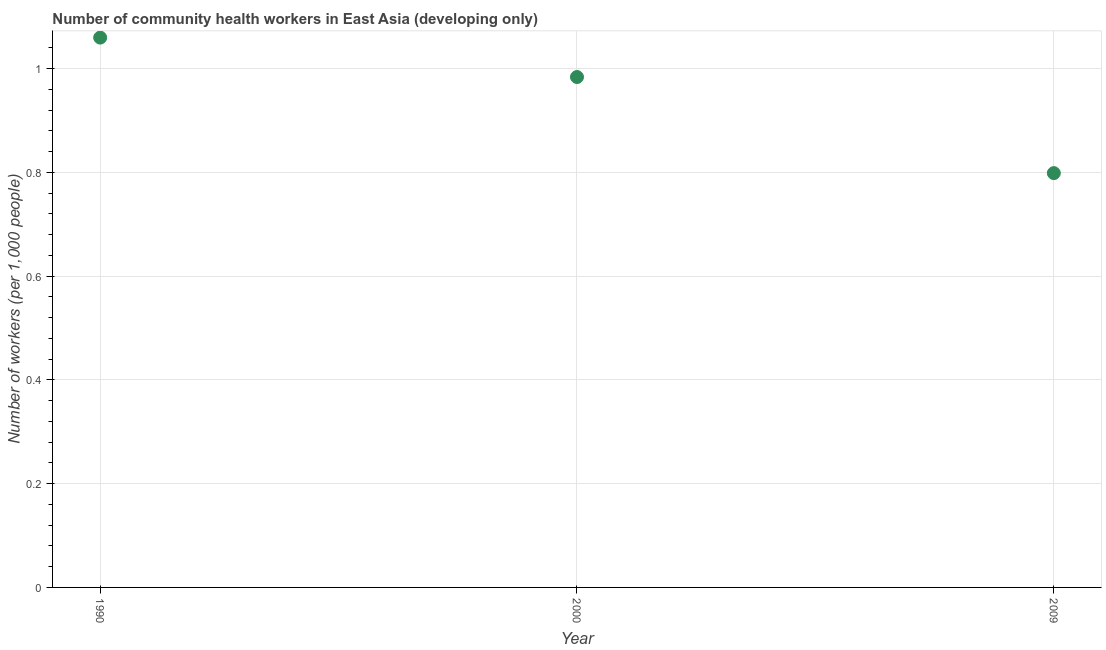What is the number of community health workers in 1990?
Provide a succinct answer. 1.06. Across all years, what is the maximum number of community health workers?
Provide a short and direct response. 1.06. Across all years, what is the minimum number of community health workers?
Keep it short and to the point. 0.8. In which year was the number of community health workers minimum?
Offer a very short reply. 2009. What is the sum of the number of community health workers?
Offer a terse response. 2.84. What is the difference between the number of community health workers in 2000 and 2009?
Offer a very short reply. 0.19. What is the average number of community health workers per year?
Offer a very short reply. 0.95. What is the median number of community health workers?
Provide a succinct answer. 0.98. In how many years, is the number of community health workers greater than 0.2 ?
Provide a succinct answer. 3. Do a majority of the years between 2009 and 2000 (inclusive) have number of community health workers greater than 0.88 ?
Give a very brief answer. No. What is the ratio of the number of community health workers in 1990 to that in 2000?
Offer a terse response. 1.08. What is the difference between the highest and the second highest number of community health workers?
Provide a succinct answer. 0.08. Is the sum of the number of community health workers in 1990 and 2009 greater than the maximum number of community health workers across all years?
Provide a short and direct response. Yes. What is the difference between the highest and the lowest number of community health workers?
Ensure brevity in your answer.  0.26. In how many years, is the number of community health workers greater than the average number of community health workers taken over all years?
Provide a short and direct response. 2. How many dotlines are there?
Ensure brevity in your answer.  1. What is the difference between two consecutive major ticks on the Y-axis?
Provide a succinct answer. 0.2. Are the values on the major ticks of Y-axis written in scientific E-notation?
Your response must be concise. No. Does the graph contain any zero values?
Offer a terse response. No. What is the title of the graph?
Keep it short and to the point. Number of community health workers in East Asia (developing only). What is the label or title of the X-axis?
Offer a very short reply. Year. What is the label or title of the Y-axis?
Provide a short and direct response. Number of workers (per 1,0 people). What is the Number of workers (per 1,000 people) in 1990?
Give a very brief answer. 1.06. What is the Number of workers (per 1,000 people) in 2000?
Provide a succinct answer. 0.98. What is the Number of workers (per 1,000 people) in 2009?
Your response must be concise. 0.8. What is the difference between the Number of workers (per 1,000 people) in 1990 and 2000?
Offer a very short reply. 0.08. What is the difference between the Number of workers (per 1,000 people) in 1990 and 2009?
Offer a terse response. 0.26. What is the difference between the Number of workers (per 1,000 people) in 2000 and 2009?
Your response must be concise. 0.19. What is the ratio of the Number of workers (per 1,000 people) in 1990 to that in 2000?
Keep it short and to the point. 1.08. What is the ratio of the Number of workers (per 1,000 people) in 1990 to that in 2009?
Give a very brief answer. 1.33. What is the ratio of the Number of workers (per 1,000 people) in 2000 to that in 2009?
Offer a very short reply. 1.23. 